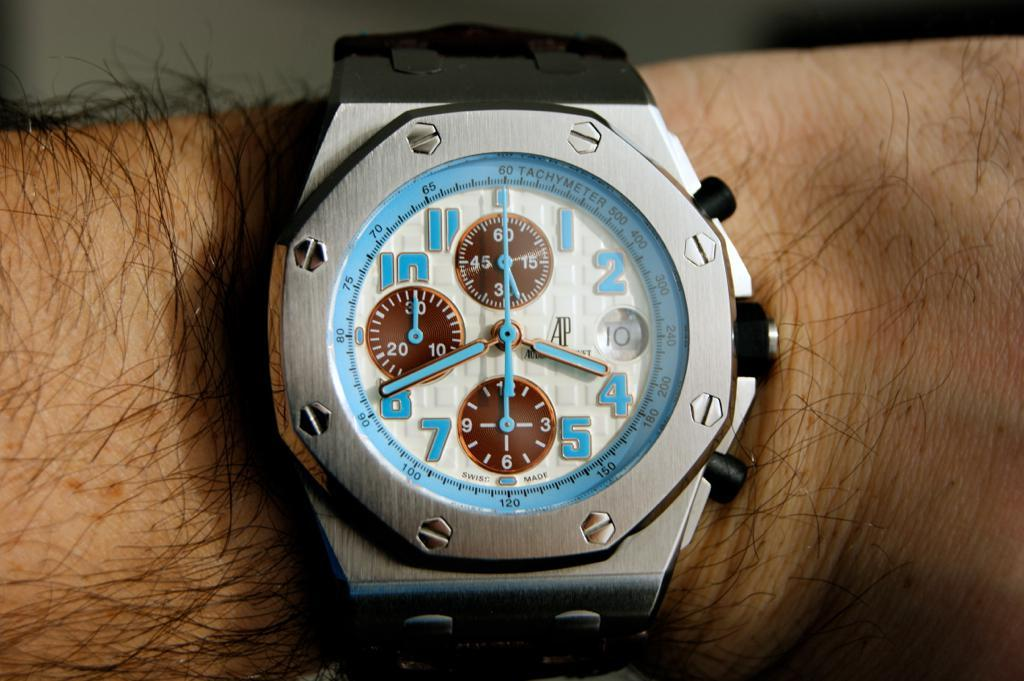<image>
Create a compact narrative representing the image presented. A swiss made wristwatch is displayed on a persons arm with a silver face and black wrist band. 